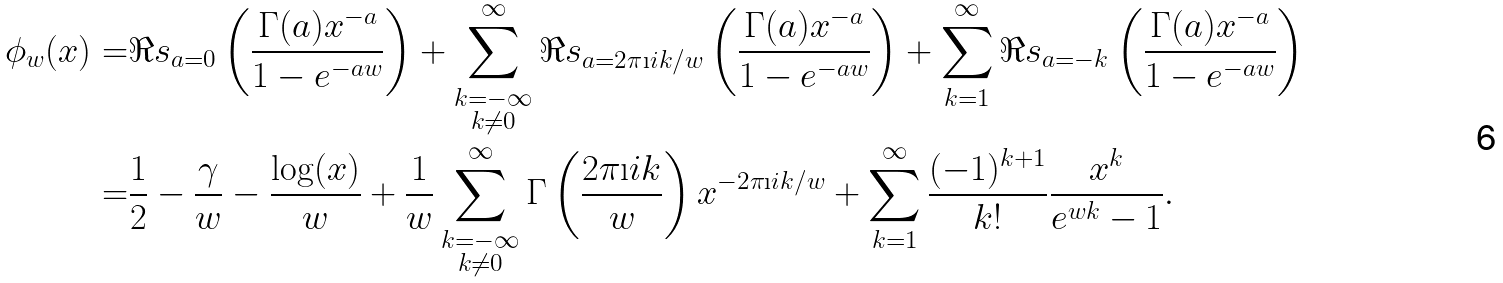Convert formula to latex. <formula><loc_0><loc_0><loc_500><loc_500>\phi _ { w } ( x ) = & \Re s _ { a = 0 } \left ( \frac { \Gamma ( a ) x ^ { - a } } { 1 - e ^ { - a w } } \right ) + \sum _ { \substack { k = - \infty \\ k \not = 0 } } ^ { \infty } \Re s _ { a = 2 \pi \i i k / w } \left ( \frac { \Gamma ( a ) x ^ { - a } } { 1 - e ^ { - a w } } \right ) + \sum _ { k = 1 } ^ { \infty } \Re s _ { a = - k } \left ( \frac { \Gamma ( a ) x ^ { - a } } { 1 - e ^ { - a w } } \right ) \\ = & \frac { 1 } { 2 } - \frac { \gamma } { w } - \frac { \log ( x ) } { w } + \frac { 1 } { w } \sum _ { \substack { k = - \infty \\ k \not = 0 } } ^ { \infty } \Gamma \left ( \frac { 2 \pi \i i k } { w } \right ) x ^ { - 2 \pi \i i k / w } + \sum _ { k = 1 } ^ { \infty } \frac { ( - 1 ) ^ { k + 1 } } { k ! } \frac { x ^ { k } } { e ^ { w k } - 1 } .</formula> 